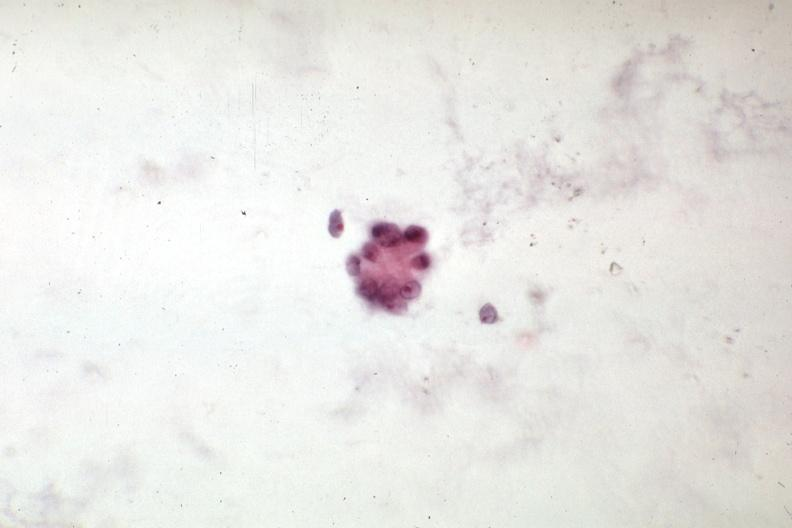s peritoneal fluid present?
Answer the question using a single word or phrase. Yes 